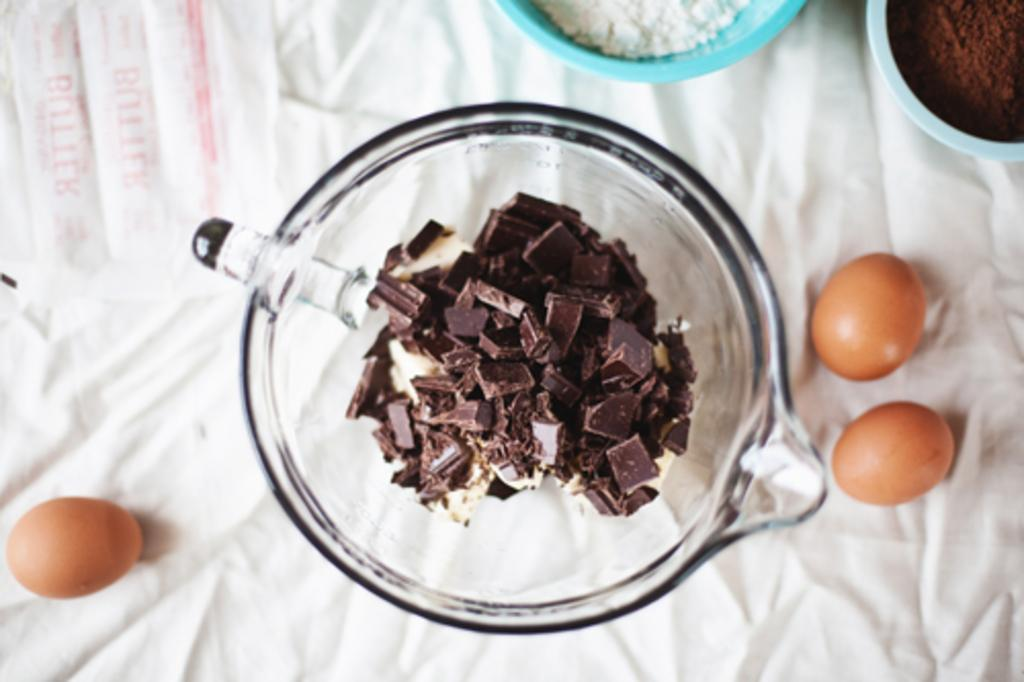What is located in the center of the image? There is a table in the center of the image. What is covering the table? There is a cloth on the table. What objects can be seen on the table? There are bowls on the table, as well as eggs. What is inside the bowls? There are chocolates and powder in the bowls. How many dogs are present in the image? There are no dogs present in the image. What type of shop can be seen in the background of the image? There is no shop visible in the image; it only shows a table with various items on it. 